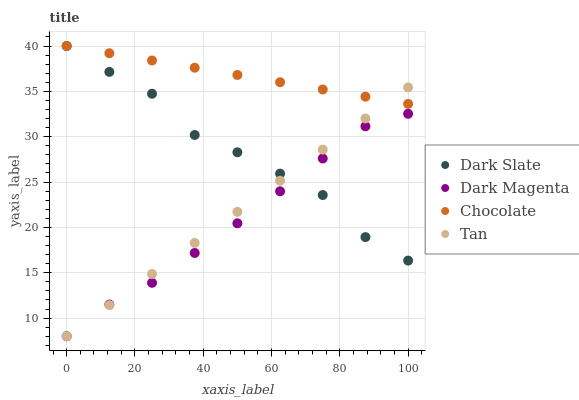Does Dark Magenta have the minimum area under the curve?
Answer yes or no. Yes. Does Chocolate have the maximum area under the curve?
Answer yes or no. Yes. Does Tan have the minimum area under the curve?
Answer yes or no. No. Does Tan have the maximum area under the curve?
Answer yes or no. No. Is Tan the smoothest?
Answer yes or no. Yes. Is Dark Slate the roughest?
Answer yes or no. Yes. Is Dark Magenta the smoothest?
Answer yes or no. No. Is Dark Magenta the roughest?
Answer yes or no. No. Does Tan have the lowest value?
Answer yes or no. Yes. Does Chocolate have the lowest value?
Answer yes or no. No. Does Chocolate have the highest value?
Answer yes or no. Yes. Does Tan have the highest value?
Answer yes or no. No. Is Dark Magenta less than Chocolate?
Answer yes or no. Yes. Is Chocolate greater than Dark Magenta?
Answer yes or no. Yes. Does Tan intersect Dark Slate?
Answer yes or no. Yes. Is Tan less than Dark Slate?
Answer yes or no. No. Is Tan greater than Dark Slate?
Answer yes or no. No. Does Dark Magenta intersect Chocolate?
Answer yes or no. No. 